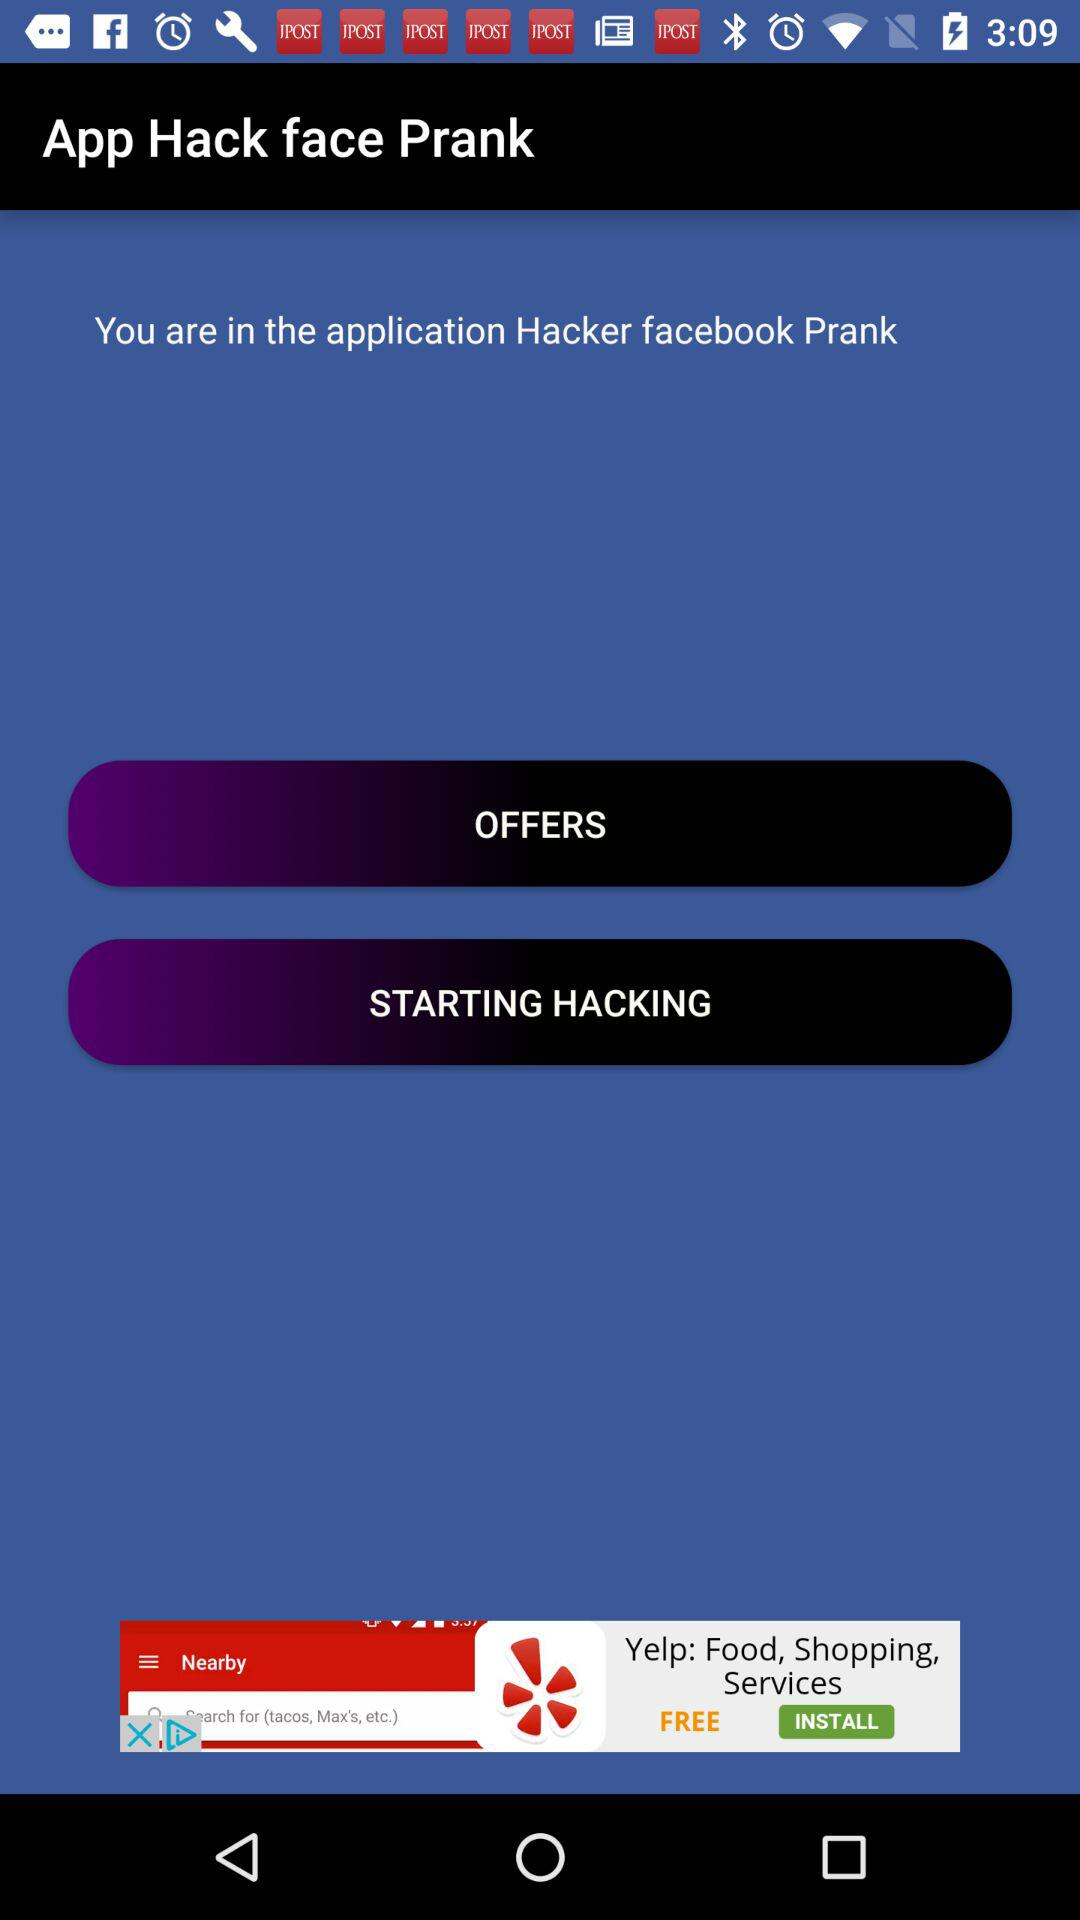When was the last login?
When the provided information is insufficient, respond with <no answer>. <no answer> 